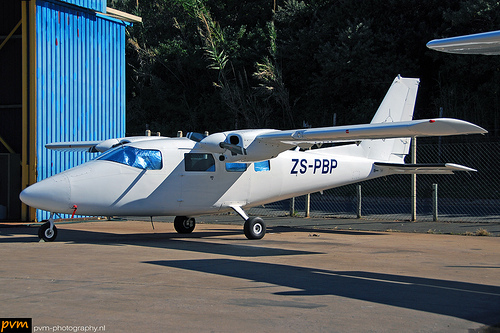<image>
Can you confirm if the plane is above the tarmac? No. The plane is not positioned above the tarmac. The vertical arrangement shows a different relationship. 